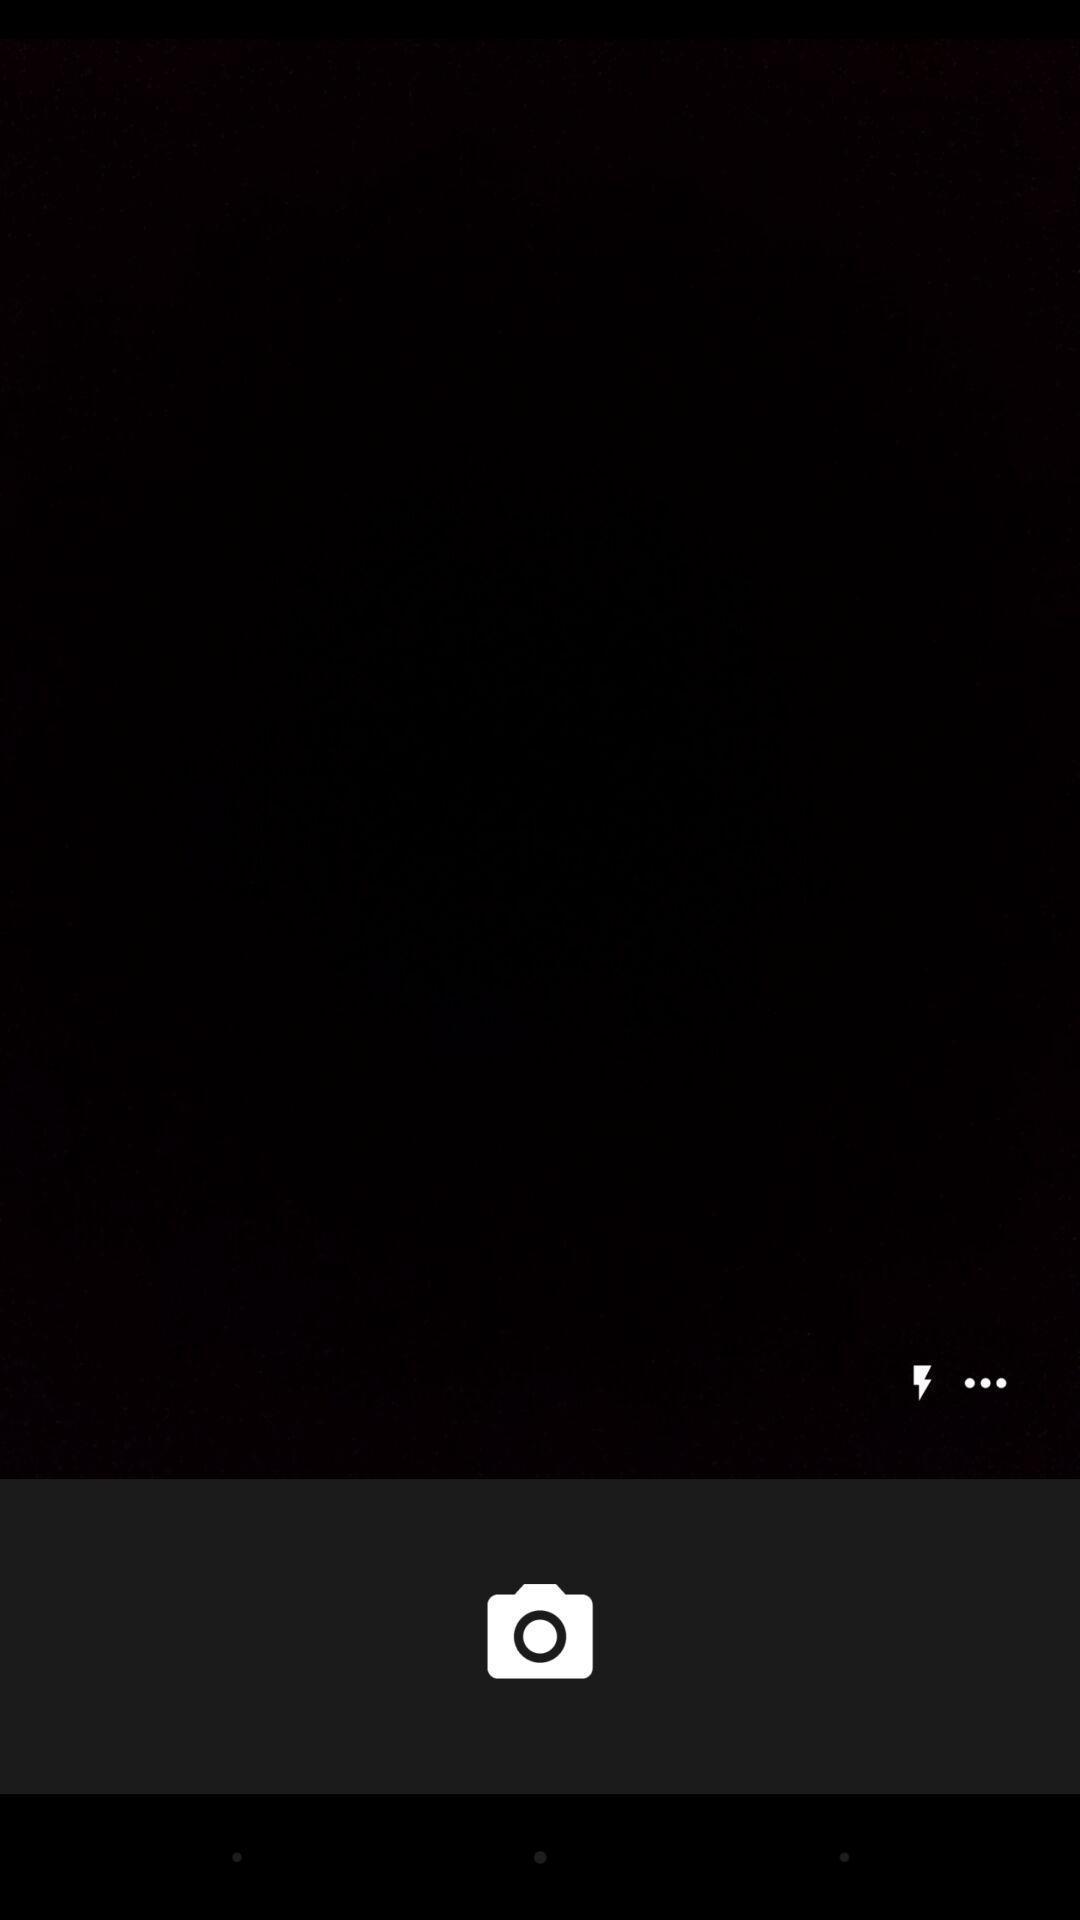Describe the key features of this screenshot. Screen showing an camera option. 